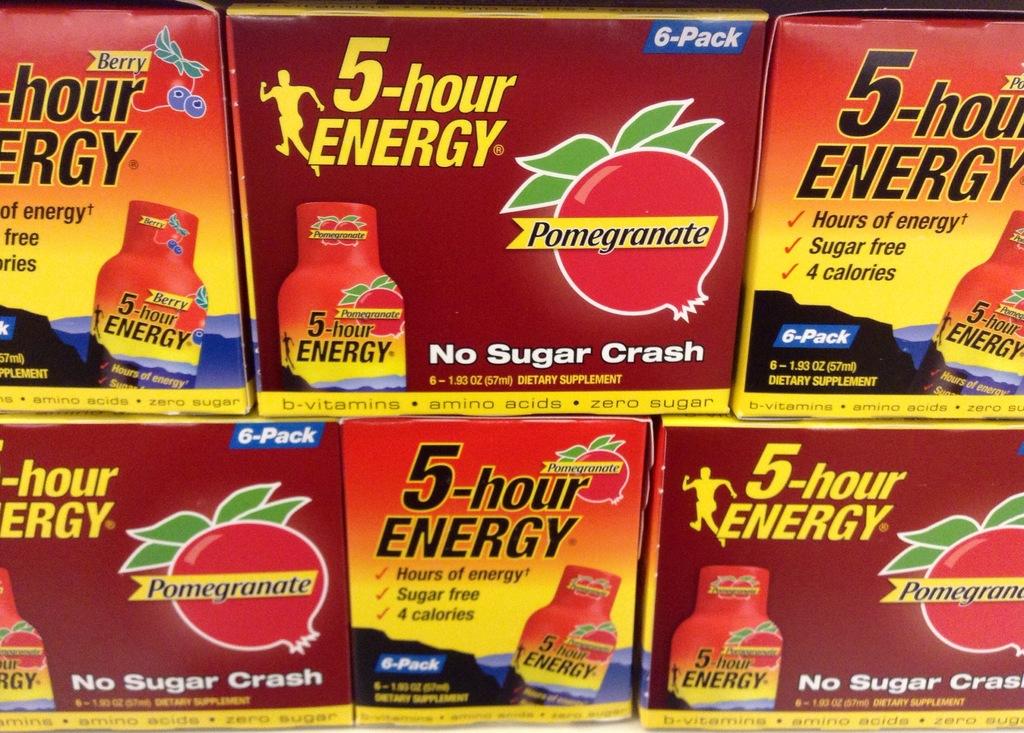How many hours of energy would this give you?
Your response must be concise. 5. What brand of energy drink is this?
Offer a very short reply. 5-hour energy. 